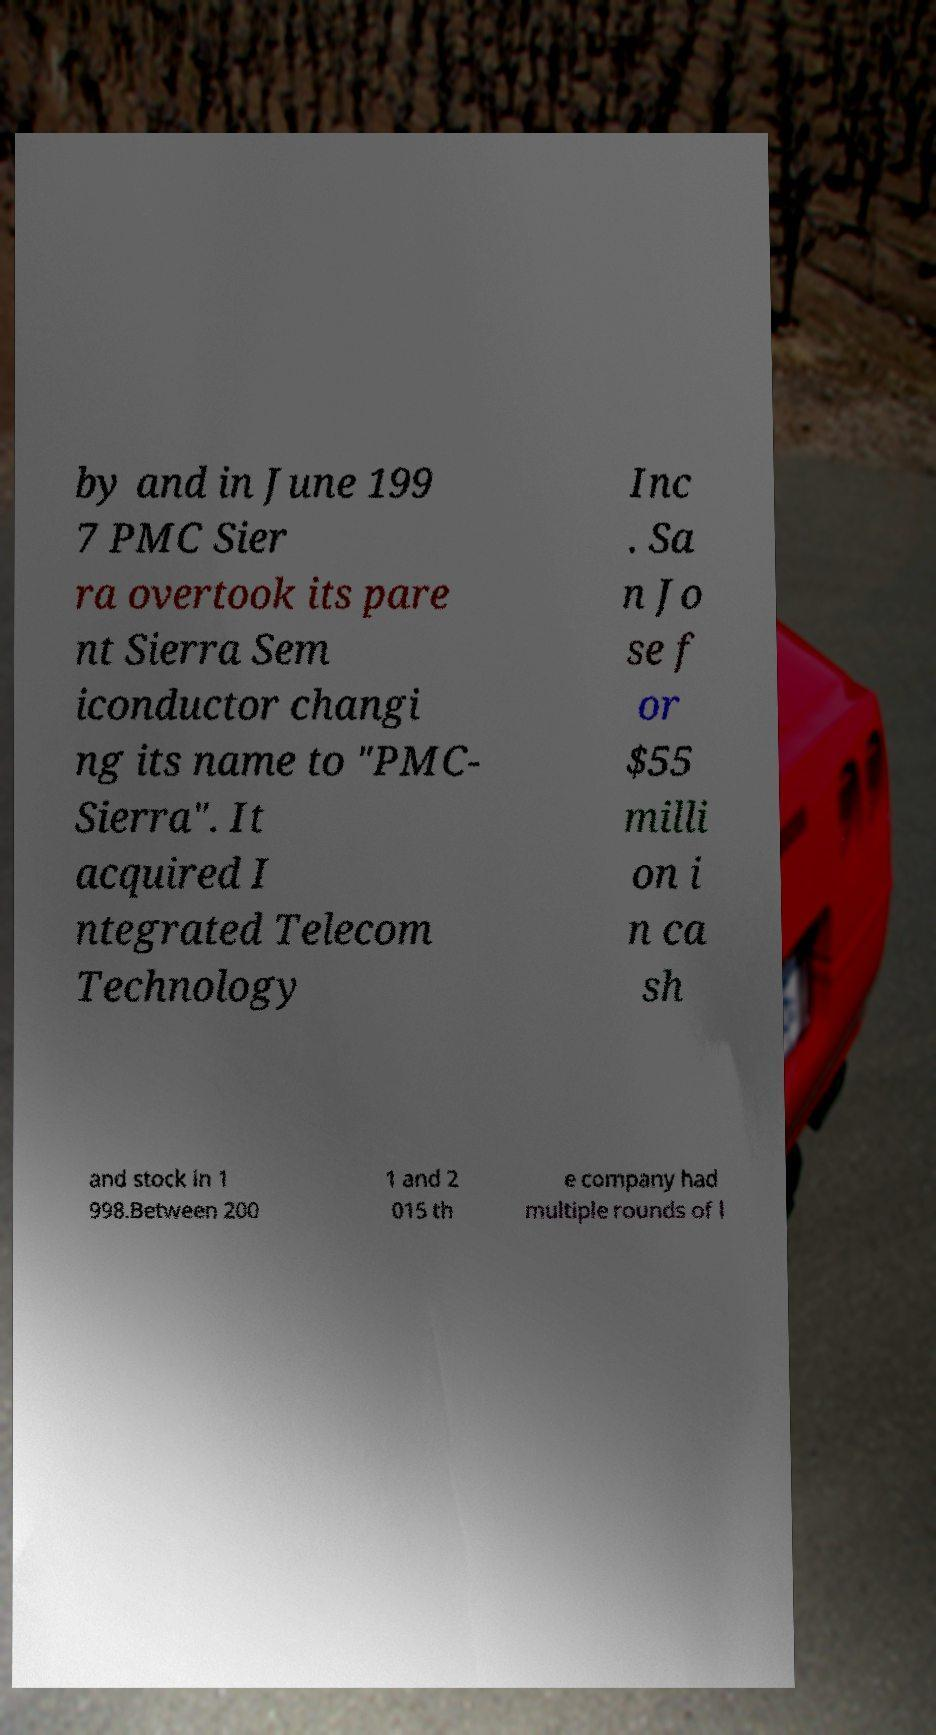What messages or text are displayed in this image? I need them in a readable, typed format. by and in June 199 7 PMC Sier ra overtook its pare nt Sierra Sem iconductor changi ng its name to "PMC- Sierra". It acquired I ntegrated Telecom Technology Inc . Sa n Jo se f or $55 milli on i n ca sh and stock in 1 998.Between 200 1 and 2 015 th e company had multiple rounds of l 